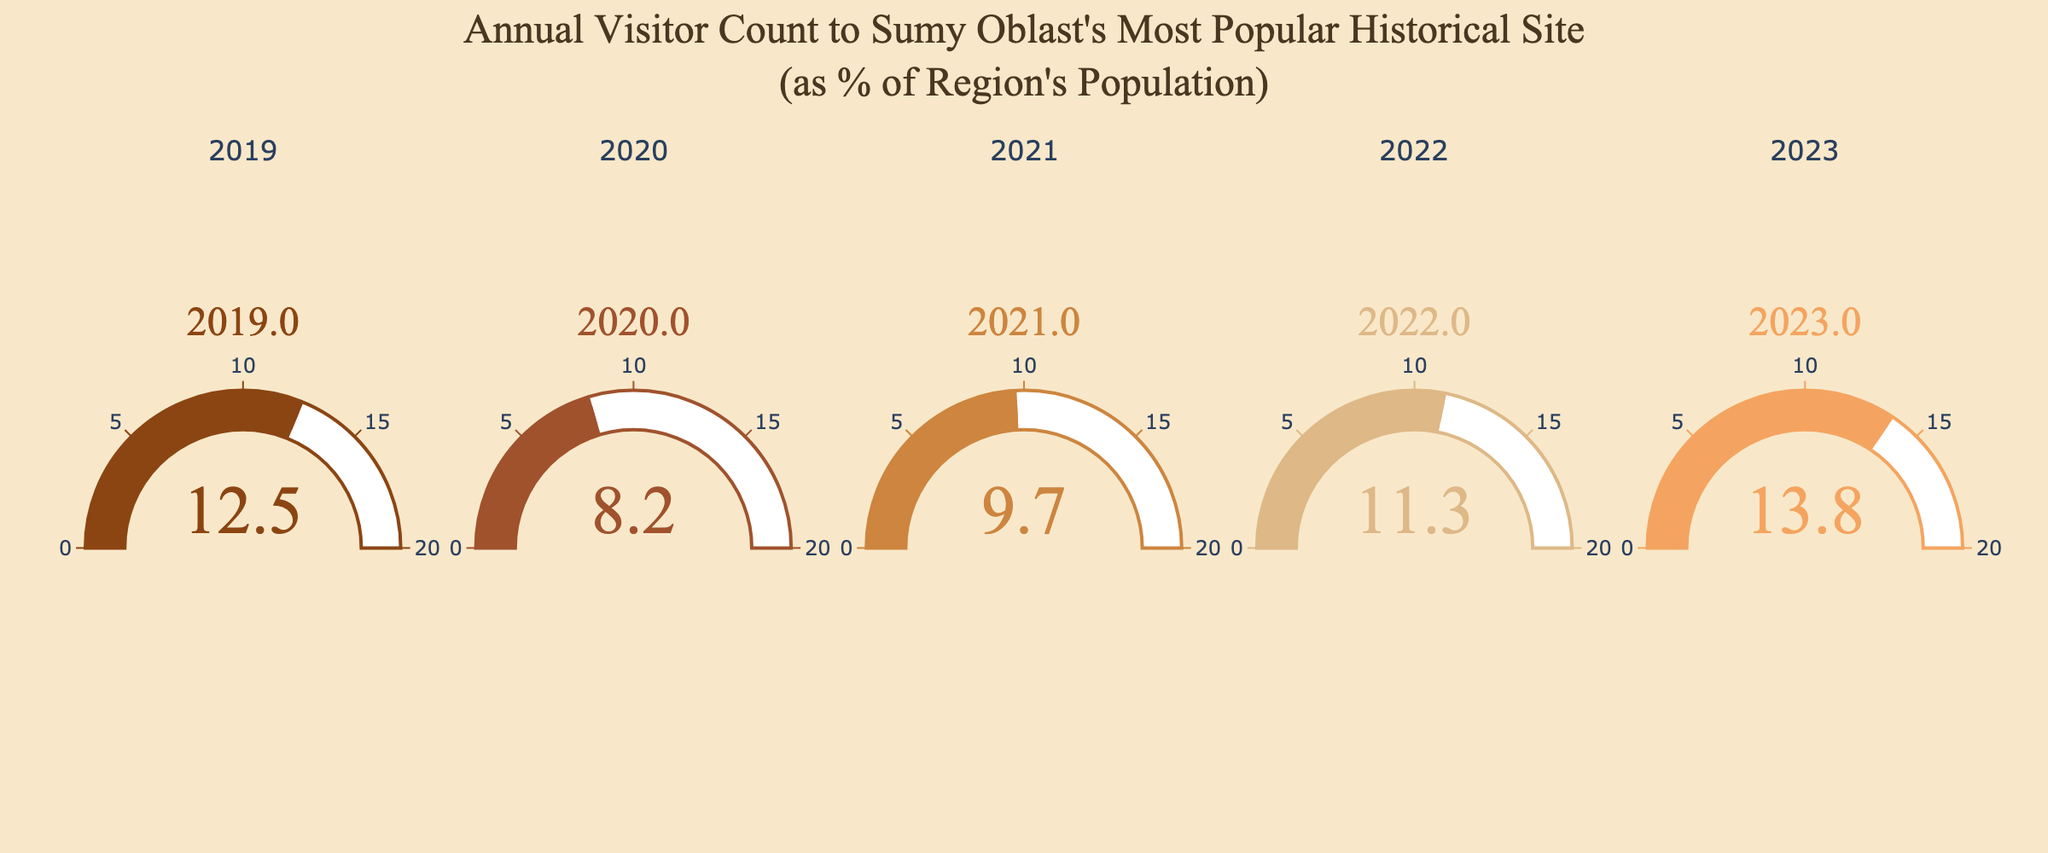what is the highest annual visitor count percentage displayed on the gauge chart? The percentage values displayed range from 8.2% to 13.8%. The highest percentage displayed on the chart is 13.8%
Answer: 13.8% which year had the lowest annual visitor count percentage? Comparing the percentages for all the years, we see that 2020 had the lowest visitor count percentage at 8.2%
Answer: 2020 how many years showed an annual visitor count percentage below 10%? The years with percentages below 10% are 2020 (8.2%) and 2021 (9.7%), making a total of 2 years
Answer: 2 which years had an annual visitor count percentage higher than 12%? The years with percentages higher than 12% are 2019 (12.5%) and 2023 (13.8%)
Answer: 2019, 2023 what was the average annual visitor count percentage from 2019 to 2023? Adding all percentage values: 12.5 + 8.2 + 9.7 + 11.3 + 13.8 = 55.5. Dividing by 5 years, the average percentage is 55.5 / 5 = 11.1%
Answer: 11.1% how did the annual visitor count percentage in 2022 compare to that in 2021? The percentage in 2021 was 9.7%, and in 2022 it increased to 11.3%. Therefore, 2022 had a higher percentage than 2021
Answer: 2022 was higher is there a noticeable trend in the annual visitor count percentage from 2019 to 2023? if so, what is it? Observing the percentages: 2019 (12.5%), 2020 (8.2%), 2021 (9.7%), 2022 (11.3%), 2023 (13.8%). The trend shows a decline from 2019 to 2020, followed by a gradual increase each year until 2023.
Answer: Decrease then increase what was the difference in annual visitor count percentage between the highest and lowest years? The highest percentage was 13.8% in 2023 and the lowest was 8.2% in 2020. The difference is 13.8 - 8.2 = 5.6%
Answer: 5.6% how did the annual visitor count percentage change from 2020 to 2021? The percentage in 2020 was 8.2%, and it increased to 9.7% in 2021. The change is 9.7 - 8.2 = 1.5%
Answer: Increased by 1.5% 